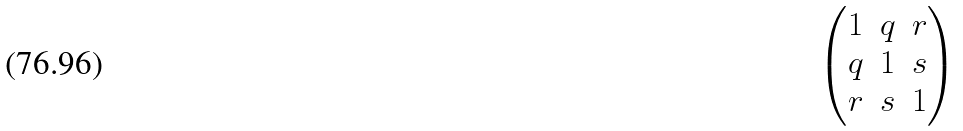Convert formula to latex. <formula><loc_0><loc_0><loc_500><loc_500>\begin{pmatrix} 1 & q & r \\ q & 1 & s \\ r & s & 1 \end{pmatrix}</formula> 